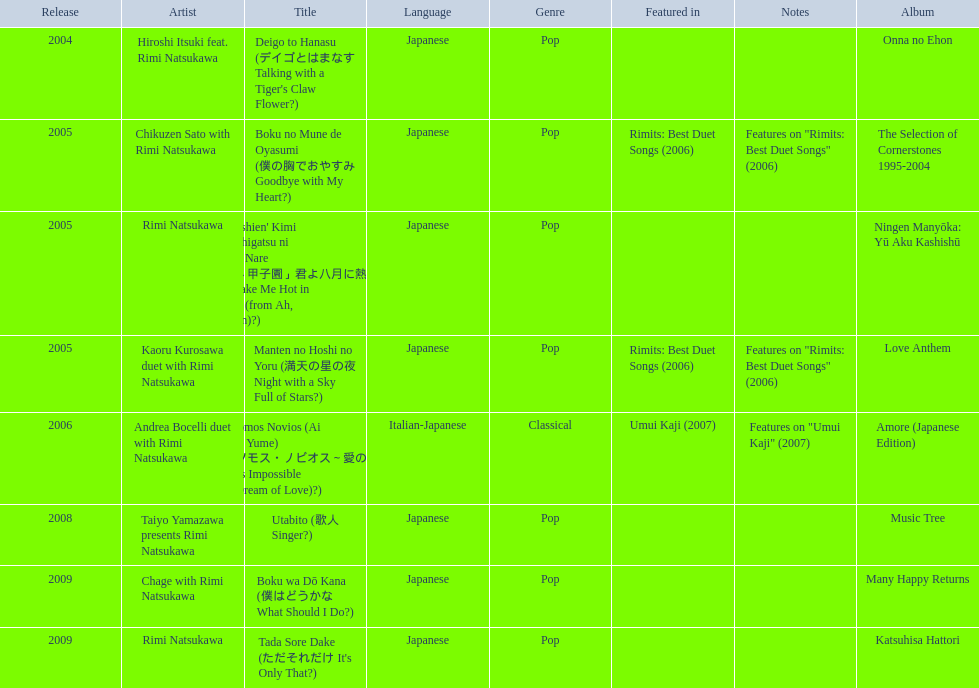When was onna no ehon released? 2004. When was the selection of cornerstones 1995-2004 released? 2005. What was released in 2008? Music Tree. 